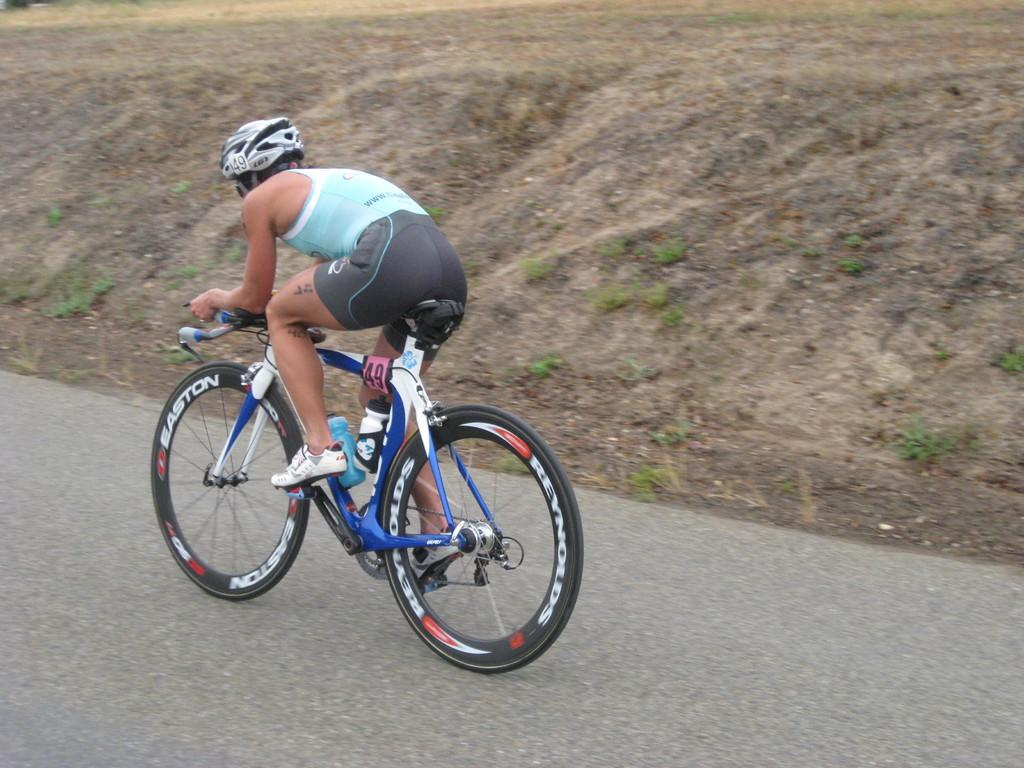Who is present in the image? There is a person in the image. What protective gear is the person wearing? The person is wearing a helmet. What type of footwear is the person wearing? The person is wearing shoes. What mode of transportation is the person using? The person is riding a bicycle. Where is the bicycle located? The bicycle is on the road. What type of environment can be seen in the background? There is grass visible in the background of the image. What is the person doing to end the wilderness in the image? There is no indication in the image that the person is trying to end the wilderness, and the image does not depict a wilderness setting. 